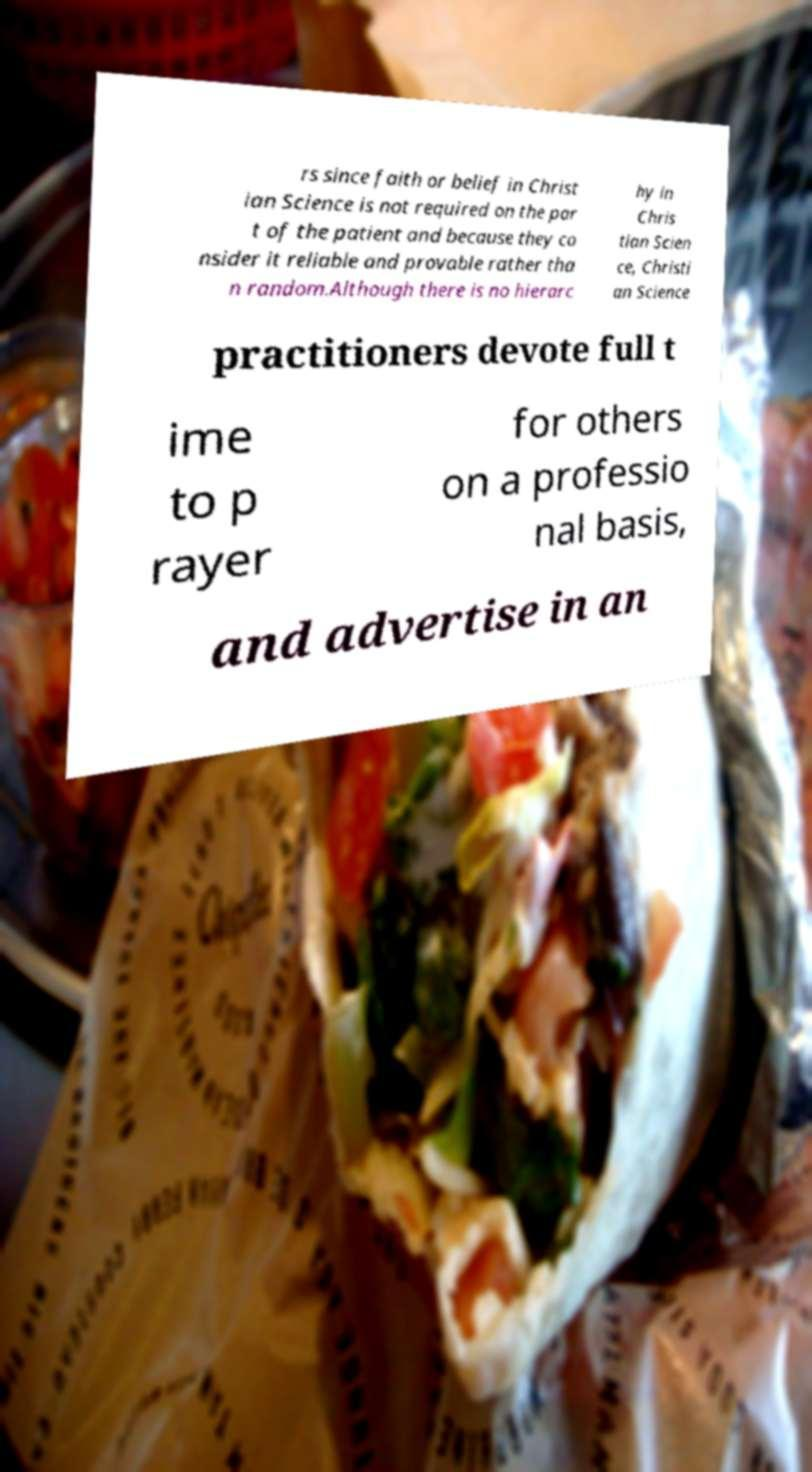What messages or text are displayed in this image? I need them in a readable, typed format. rs since faith or belief in Christ ian Science is not required on the par t of the patient and because they co nsider it reliable and provable rather tha n random.Although there is no hierarc hy in Chris tian Scien ce, Christi an Science practitioners devote full t ime to p rayer for others on a professio nal basis, and advertise in an 